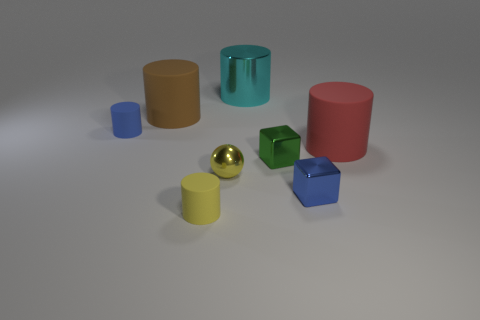Subtract all blue cylinders. How many cylinders are left? 4 Add 2 small metallic cylinders. How many objects exist? 10 Subtract 1 blocks. How many blocks are left? 1 Subtract all blocks. How many objects are left? 6 Subtract all red spheres. How many blue cubes are left? 1 Subtract all red metal cylinders. Subtract all yellow objects. How many objects are left? 6 Add 3 blocks. How many blocks are left? 5 Add 5 tiny blue blocks. How many tiny blue blocks exist? 6 Subtract all blue cylinders. How many cylinders are left? 4 Subtract 0 purple blocks. How many objects are left? 8 